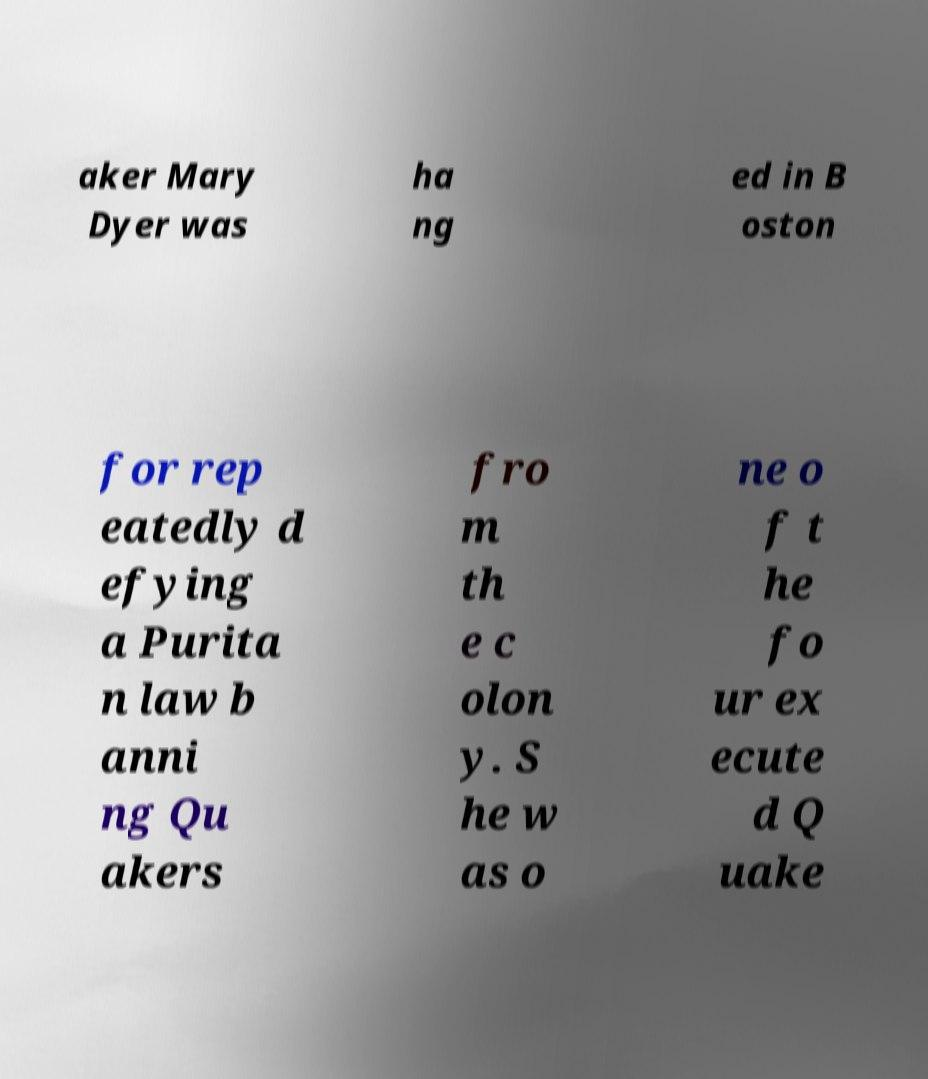Could you extract and type out the text from this image? aker Mary Dyer was ha ng ed in B oston for rep eatedly d efying a Purita n law b anni ng Qu akers fro m th e c olon y. S he w as o ne o f t he fo ur ex ecute d Q uake 